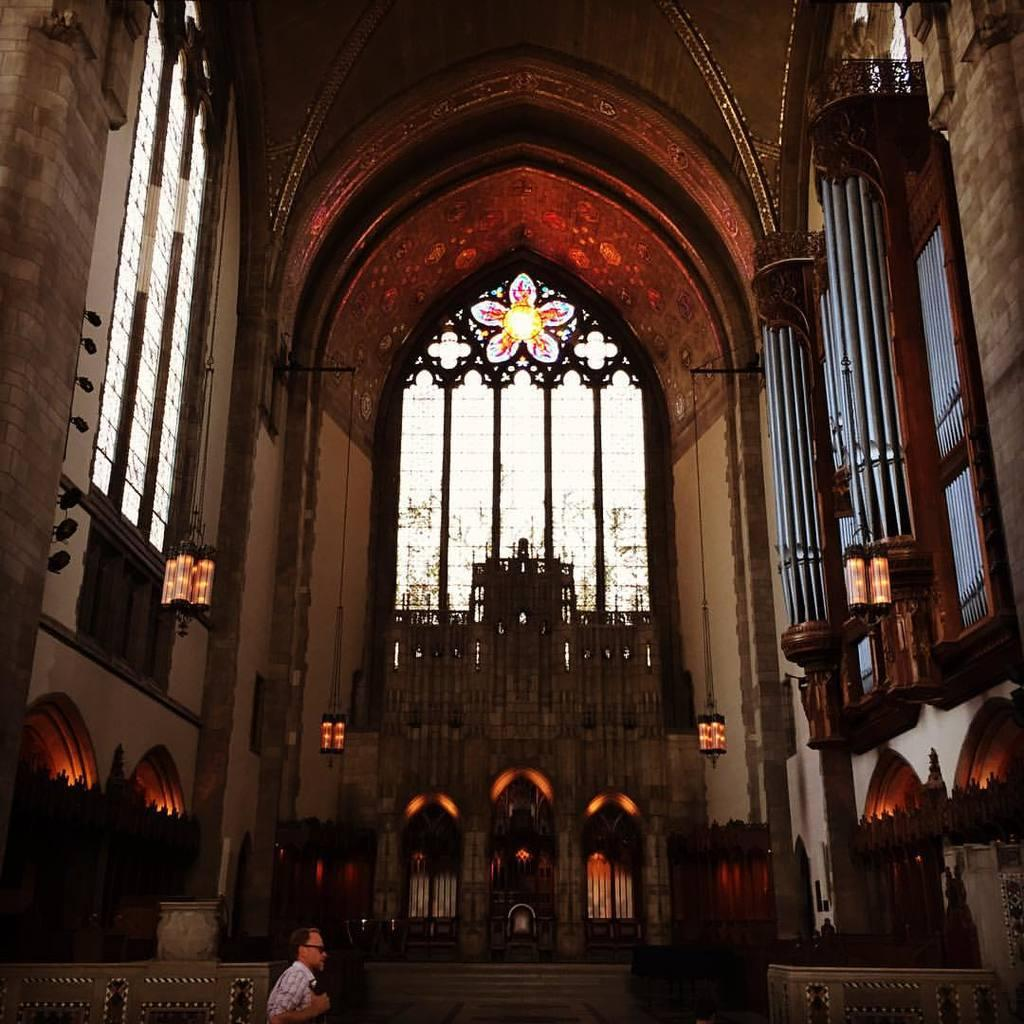What type of location is depicted in the image? The image is an inside view of a building. What architectural features can be seen in the building? There are arches, lights, and pillars visible in the building. Can you describe any other elements visible in the building? There are other unspecified elements visible in the building. What time of day is it at the lake in the image? There is no lake present in the image; it is an inside view of a building. How does the bomb affect the structure of the building in the image? There is no bomb present in the image; it is an inside view of a building with no signs of damage or destruction. 